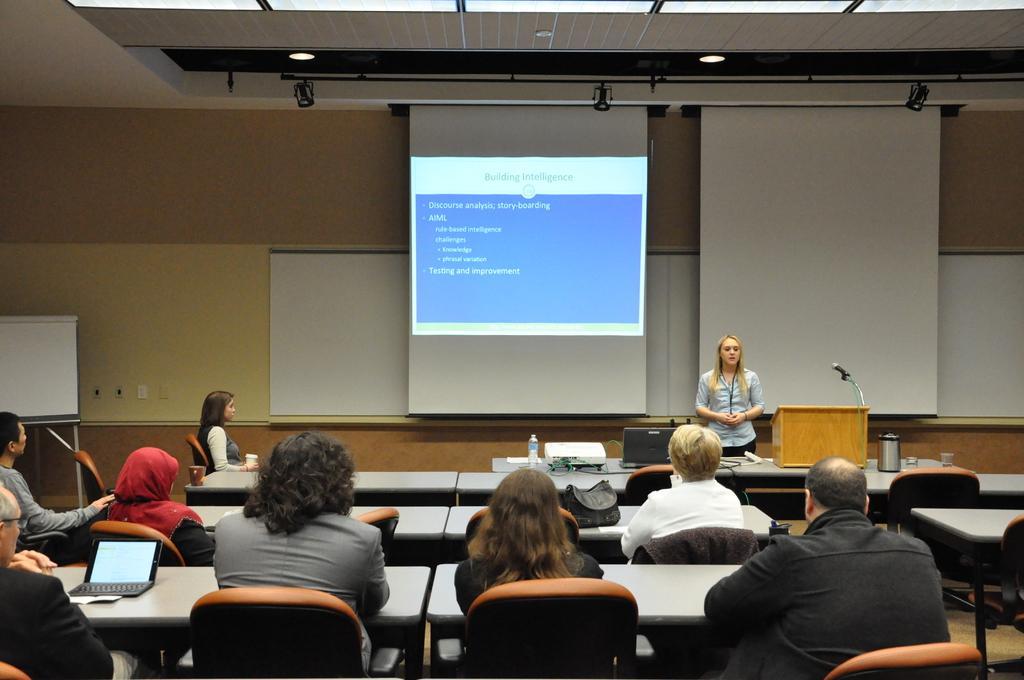Can you describe this image briefly? There are some people sitting on chairs. There are tables. In the back there is a screen and boards. And a lady is standing. In front of her there is a table with stand, mic, kettle, glasses, bottle and many other items. 